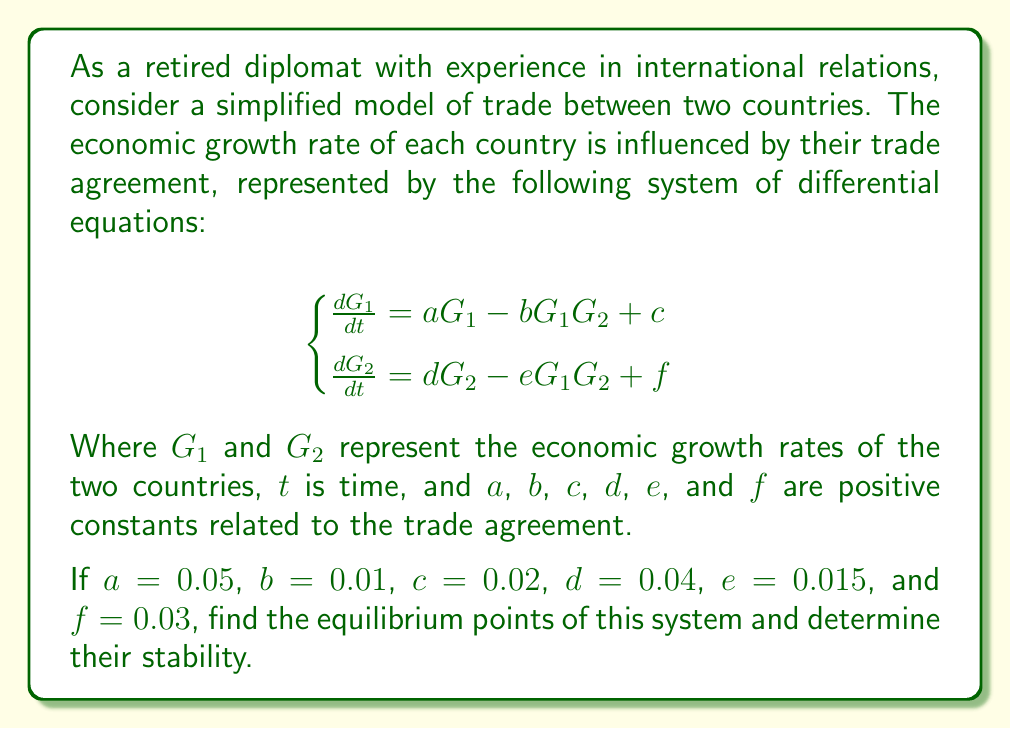Show me your answer to this math problem. To solve this problem, we'll follow these steps:

1) Find the equilibrium points by setting the derivatives to zero:

$$\begin{cases}
0 = 0.05G_1 - 0.01G_1G_2 + 0.02 \\
0 = 0.04G_2 - 0.015G_1G_2 + 0.03
\end{cases}$$

2) Solve this system of equations:

From the first equation:
$G_2 = 5 + \frac{2}{G_1}$

Substitute this into the second equation:
$0 = 0.04(5 + \frac{2}{G_1}) - 0.015G_1(5 + \frac{2}{G_1}) + 0.03$

Simplify:
$0 = 0.2 + \frac{0.08}{G_1} - 0.075G_1 - 0.03 + 0.03$
$0 = 0.2 + \frac{0.08}{G_1} - 0.075G_1$

Multiply by $G_1$:
$0 = 0.2G_1 + 0.08 - 0.075G_1^2$

Rearrange:
$0.075G_1^2 - 0.2G_1 - 0.08 = 0$

Solve this quadratic equation:
$G_1 \approx 2.9035$ or $G_1 \approx -0.3668$

Since $G_1$ represents economic growth rate, we discard the negative solution.

For $G_1 \approx 2.9035$, we can find $G_2$:
$G_2 = 5 + \frac{2}{2.9035} \approx 5.6887$

Therefore, the equilibrium point is approximately $(2.9035, 5.6887)$.

3) To determine stability, we need to find the Jacobian matrix and evaluate its eigenvalues at the equilibrium point:

$$J = \begin{bmatrix}
0.05 - 0.01G_2 & -0.01G_1 \\
-0.015G_2 & 0.04 - 0.015G_1
\end{bmatrix}$$

At the equilibrium point:

$$J \approx \begin{bmatrix}
-0.006887 & -0.029035 \\
-0.085331 & -0.003553
\end{bmatrix}$$

4) Calculate the eigenvalues:

$det(J - \lambda I) = 0$

$\lambda^2 + 0.01044\lambda + 0.000024 = 0$

Solving this quadratic equation gives:
$\lambda_1 \approx -0.010438$ and $\lambda_2 \approx -0.000002$

Since both eigenvalues are negative, the equilibrium point is stable.
Answer: Equilibrium point: $(2.9035, 5.6887)$; Stable 